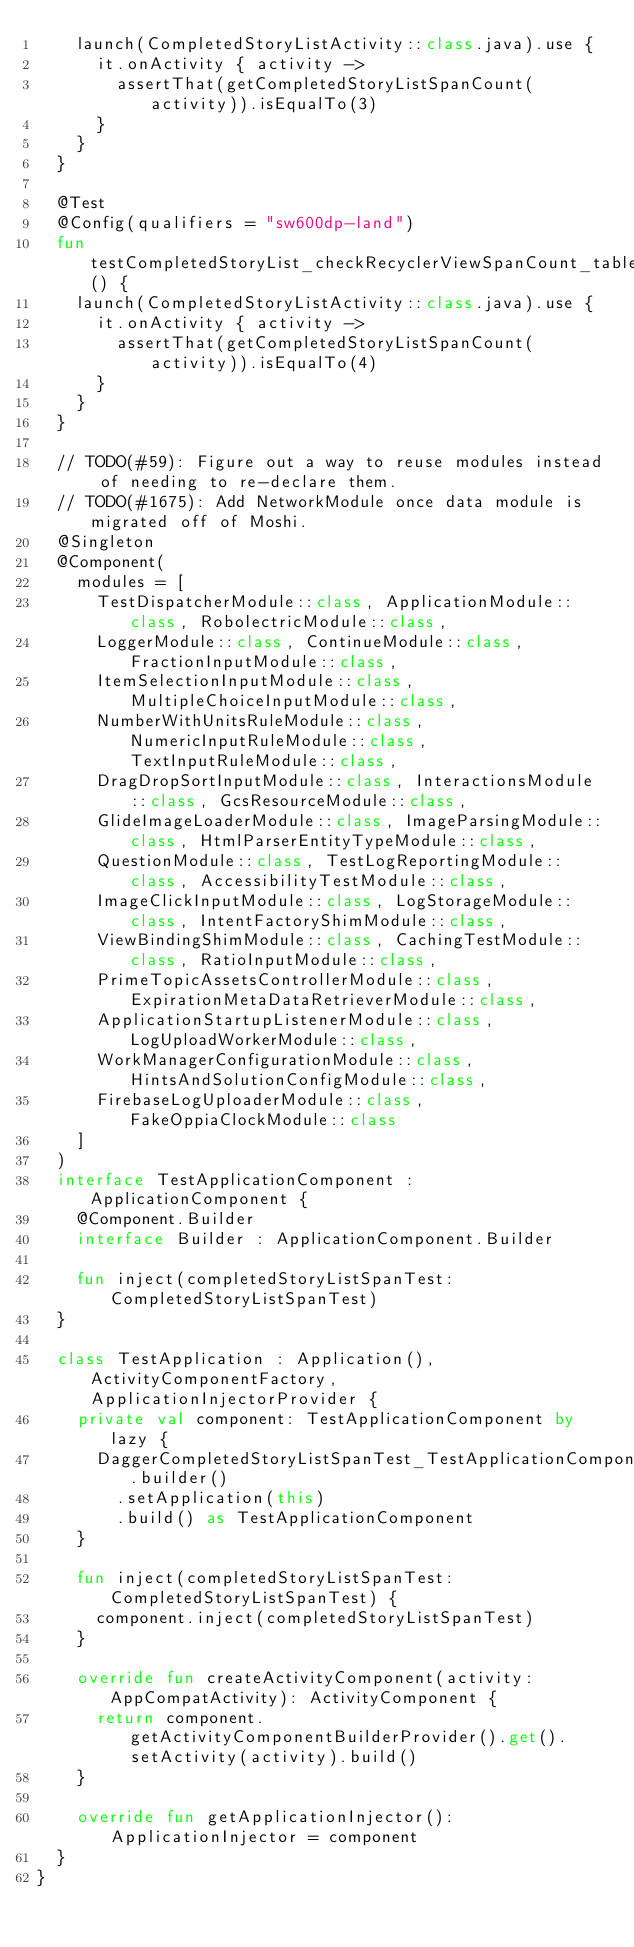<code> <loc_0><loc_0><loc_500><loc_500><_Kotlin_>    launch(CompletedStoryListActivity::class.java).use {
      it.onActivity { activity ->
        assertThat(getCompletedStoryListSpanCount(activity)).isEqualTo(3)
      }
    }
  }

  @Test
  @Config(qualifiers = "sw600dp-land")
  fun testCompletedStoryList_checkRecyclerViewSpanCount_tabletLand_spanIsCorrect() {
    launch(CompletedStoryListActivity::class.java).use {
      it.onActivity { activity ->
        assertThat(getCompletedStoryListSpanCount(activity)).isEqualTo(4)
      }
    }
  }

  // TODO(#59): Figure out a way to reuse modules instead of needing to re-declare them.
  // TODO(#1675): Add NetworkModule once data module is migrated off of Moshi.
  @Singleton
  @Component(
    modules = [
      TestDispatcherModule::class, ApplicationModule::class, RobolectricModule::class,
      LoggerModule::class, ContinueModule::class, FractionInputModule::class,
      ItemSelectionInputModule::class, MultipleChoiceInputModule::class,
      NumberWithUnitsRuleModule::class, NumericInputRuleModule::class, TextInputRuleModule::class,
      DragDropSortInputModule::class, InteractionsModule::class, GcsResourceModule::class,
      GlideImageLoaderModule::class, ImageParsingModule::class, HtmlParserEntityTypeModule::class,
      QuestionModule::class, TestLogReportingModule::class, AccessibilityTestModule::class,
      ImageClickInputModule::class, LogStorageModule::class, IntentFactoryShimModule::class,
      ViewBindingShimModule::class, CachingTestModule::class, RatioInputModule::class,
      PrimeTopicAssetsControllerModule::class, ExpirationMetaDataRetrieverModule::class,
      ApplicationStartupListenerModule::class, LogUploadWorkerModule::class,
      WorkManagerConfigurationModule::class, HintsAndSolutionConfigModule::class,
      FirebaseLogUploaderModule::class, FakeOppiaClockModule::class
    ]
  )
  interface TestApplicationComponent : ApplicationComponent {
    @Component.Builder
    interface Builder : ApplicationComponent.Builder

    fun inject(completedStoryListSpanTest: CompletedStoryListSpanTest)
  }

  class TestApplication : Application(), ActivityComponentFactory, ApplicationInjectorProvider {
    private val component: TestApplicationComponent by lazy {
      DaggerCompletedStoryListSpanTest_TestApplicationComponent.builder()
        .setApplication(this)
        .build() as TestApplicationComponent
    }

    fun inject(completedStoryListSpanTest: CompletedStoryListSpanTest) {
      component.inject(completedStoryListSpanTest)
    }

    override fun createActivityComponent(activity: AppCompatActivity): ActivityComponent {
      return component.getActivityComponentBuilderProvider().get().setActivity(activity).build()
    }

    override fun getApplicationInjector(): ApplicationInjector = component
  }
}
</code> 